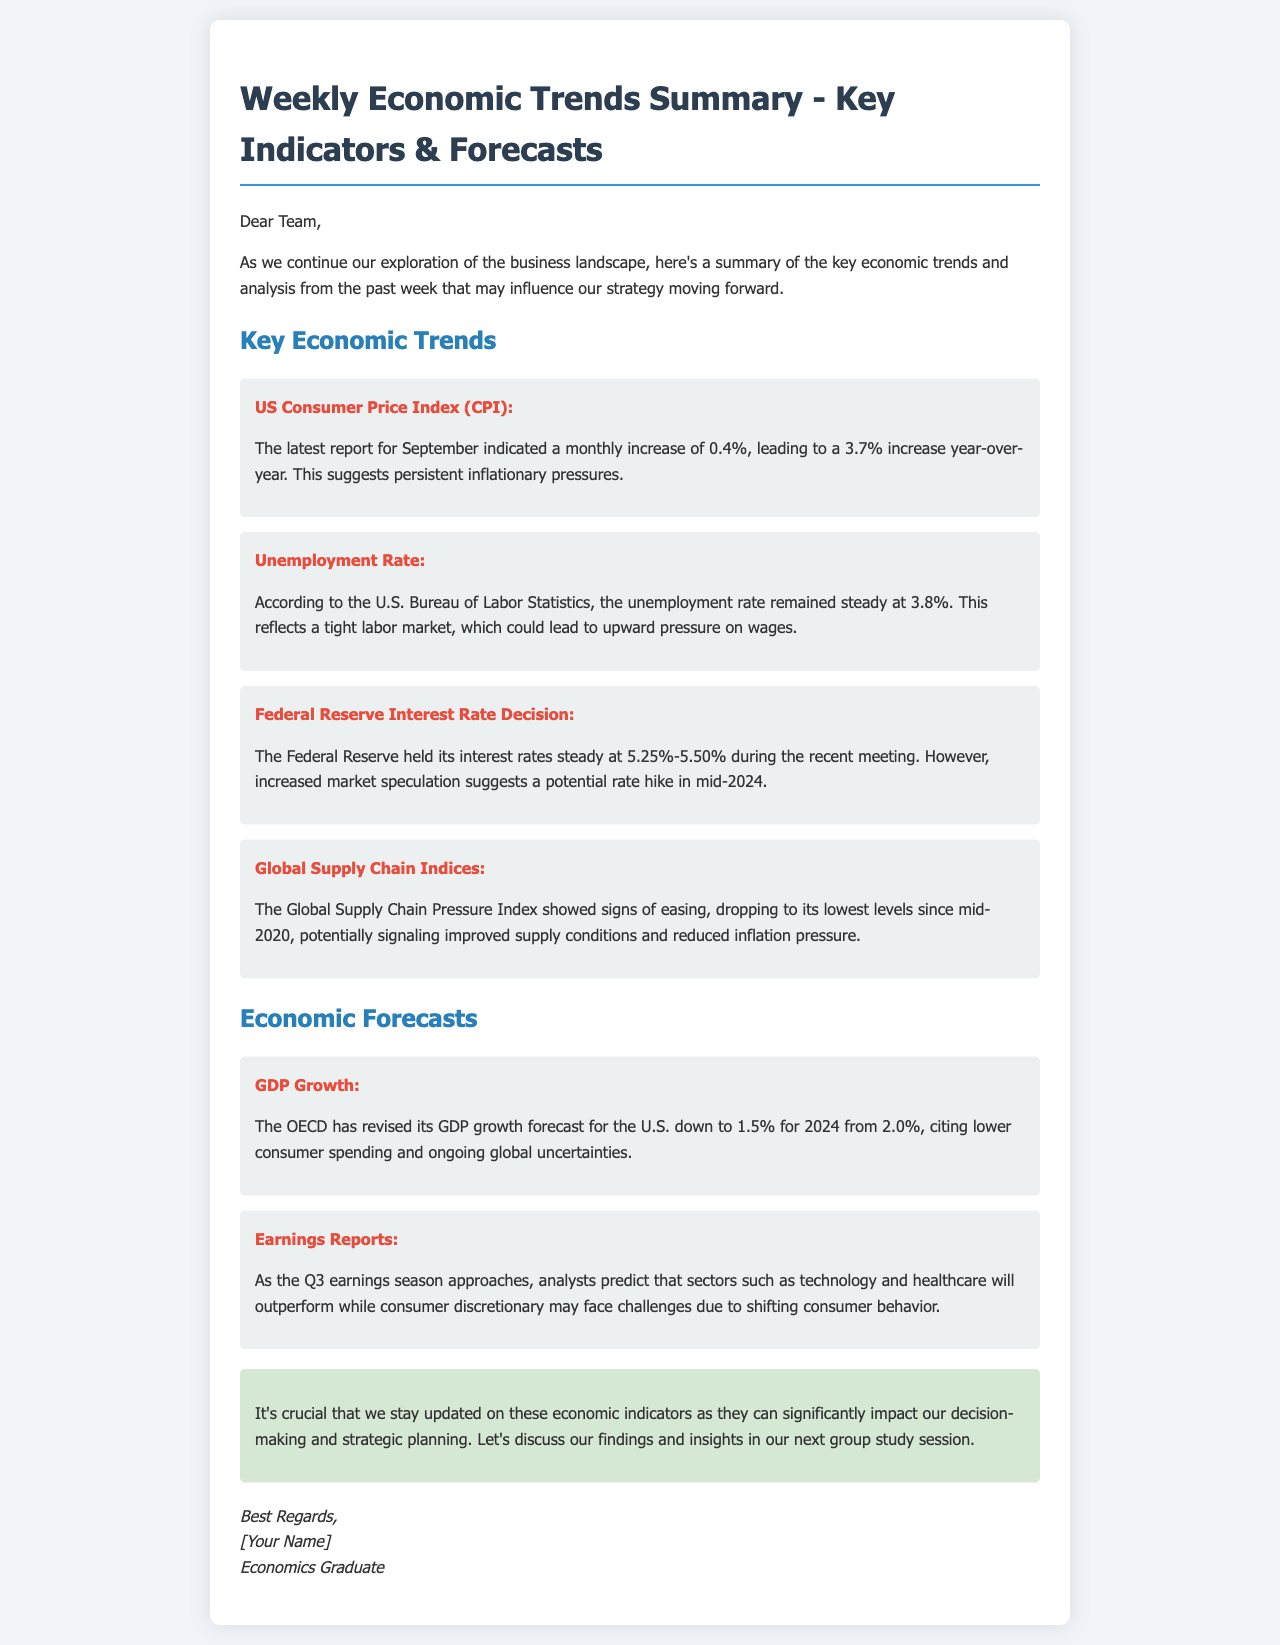What was the US Consumer Price Index increase in September? The document states there was a monthly increase of 0.4%, leading to a 3.7% increase year-over-year.
Answer: 0.4% What is the unemployment rate according to the U.S. Bureau of Labor Statistics? It mentions that the unemployment rate remained steady at 3.8%.
Answer: 3.8% What is the current Federal Reserve interest rate? The document specifies that the Federal Reserve held its interest rates steady at 5.25%-5.50%.
Answer: 5.25%-5.50% What has the OECD revised the GDP growth forecast for the U.S. to for 2024? It indicates that the GDP growth forecast was revised down to 1.5% for 2024.
Answer: 1.5% Which sectors are predicted to outperform in the Q3 earnings season? The document mentions that sectors such as technology and healthcare will outperform.
Answer: Technology and healthcare What are the signs of the Global Supply Chain Pressure Index? The document states that it showed signs of easing, dropping to its lowest levels since mid-2020.
Answer: Easing Why is it important to stay updated on economic indicators? It highlights that these indicators can significantly impact decision-making and strategic planning.
Answer: Significant impact What will be discussed in the next group study session? The document suggests discussing the findings and insights related to economic indicators.
Answer: Findings and insights 